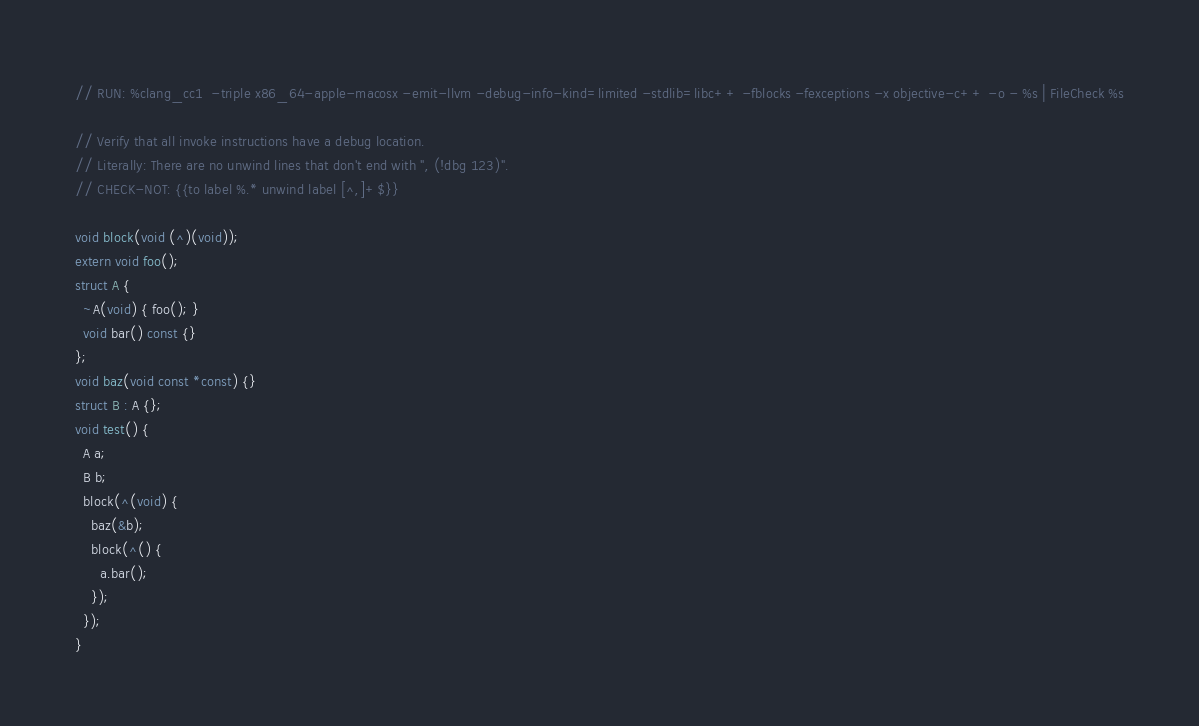Convert code to text. <code><loc_0><loc_0><loc_500><loc_500><_ObjectiveC_>// RUN: %clang_cc1  -triple x86_64-apple-macosx -emit-llvm -debug-info-kind=limited -stdlib=libc++ -fblocks -fexceptions -x objective-c++ -o - %s | FileCheck %s

// Verify that all invoke instructions have a debug location.
// Literally: There are no unwind lines that don't end with ", (!dbg 123)".
// CHECK-NOT: {{to label %.* unwind label [^,]+$}}

void block(void (^)(void));
extern void foo();
struct A {
  ~A(void) { foo(); }
  void bar() const {}
};
void baz(void const *const) {}
struct B : A {};
void test() {
  A a;
  B b;
  block(^(void) {
    baz(&b);
    block(^() {
      a.bar();
    });
  });
}
</code> 